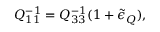<formula> <loc_0><loc_0><loc_500><loc_500>Q _ { 1 1 } ^ { - 1 } = Q _ { 3 3 } ^ { - 1 } ( 1 + \tilde { \epsilon } _ { Q } ) ,</formula> 